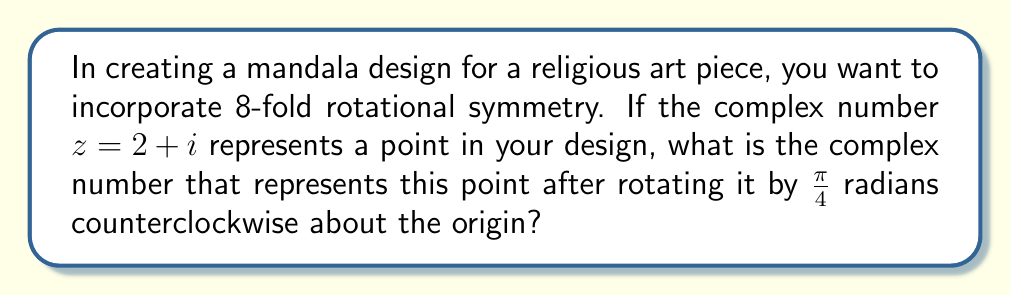Can you answer this question? To solve this problem, we'll use the properties of complex numbers and their transformations in the complex plane. Here's a step-by-step approach:

1) Rotation in the complex plane by an angle $\theta$ counterclockwise about the origin is achieved by multiplying the complex number by $e^{i\theta}$.

2) In this case, $\theta = \frac{\pi}{4}$ radians.

3) We need to calculate $z' = z \cdot e^{i\frac{\pi}{4}}$, where $z = 2 + i$.

4) Recall Euler's formula: $e^{i\theta} = \cos\theta + i\sin\theta$

5) Therefore, $e^{i\frac{\pi}{4}} = \cos\frac{\pi}{4} + i\sin\frac{\pi}{4}$

6) We know that $\cos\frac{\pi}{4} = \sin\frac{\pi}{4} = \frac{\sqrt{2}}{2}$

7) So, $e^{i\frac{\pi}{4}} = \frac{\sqrt{2}}{2} + i\frac{\sqrt{2}}{2}$

8) Now, let's multiply: 
   $z' = (2 + i) \cdot (\frac{\sqrt{2}}{2} + i\frac{\sqrt{2}}{2})$

9) Expanding this:
   $z' = (2 \cdot \frac{\sqrt{2}}{2} - 1 \cdot \frac{\sqrt{2}}{2}) + i(2 \cdot \frac{\sqrt{2}}{2} + 1 \cdot \frac{\sqrt{2}}{2})$

10) Simplifying:
    $z' = \sqrt{2} - \frac{\sqrt{2}}{2} + i(\sqrt{2} + \frac{\sqrt{2}}{2})$

11) Further simplification:
    $z' = \frac{3\sqrt{2}}{2} + i\frac{3\sqrt{2}}{2}$

This complex number represents the point $(2 + i)$ after rotation by $\frac{\pi}{4}$ radians counterclockwise about the origin.
Answer: $\frac{3\sqrt{2}}{2} + i\frac{3\sqrt{2}}{2}$ 